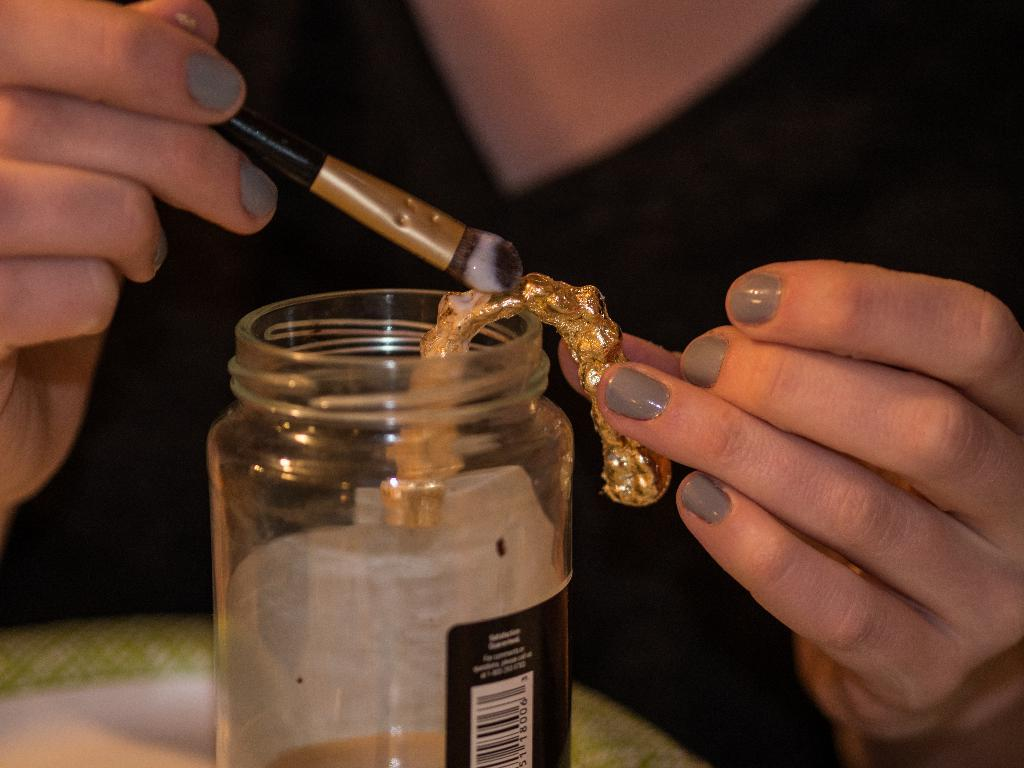Who or what is present in the image? There is a person in the image. What object is in front of the person? There is a small bottle in front of the person. What is the person holding in the image? The person is holding a brush. What type of cushion is the person sitting on in the image? There is no cushion present in the image, nor is the person sitting down. 